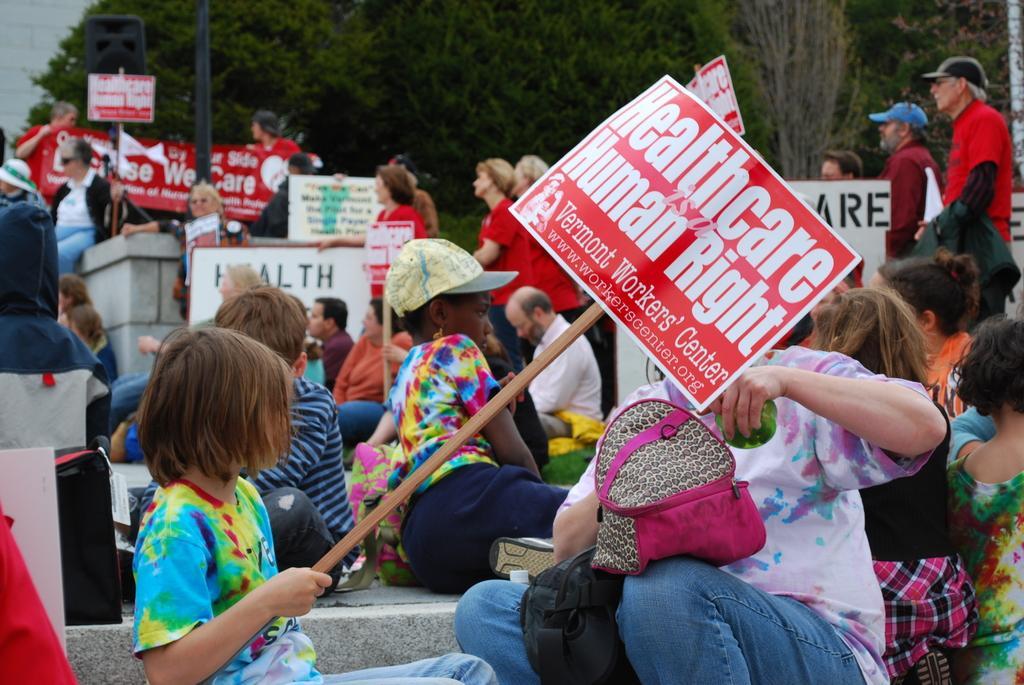Can you describe this image briefly? In this image there are group people sitting on floor and holding boards, in the background some people are standing and there are trees. 